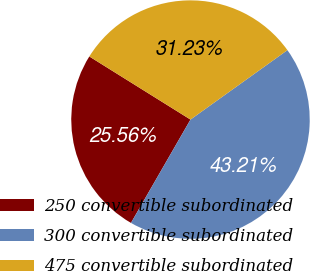<chart> <loc_0><loc_0><loc_500><loc_500><pie_chart><fcel>250 convertible subordinated<fcel>300 convertible subordinated<fcel>475 convertible subordinated<nl><fcel>25.56%<fcel>43.21%<fcel>31.23%<nl></chart> 